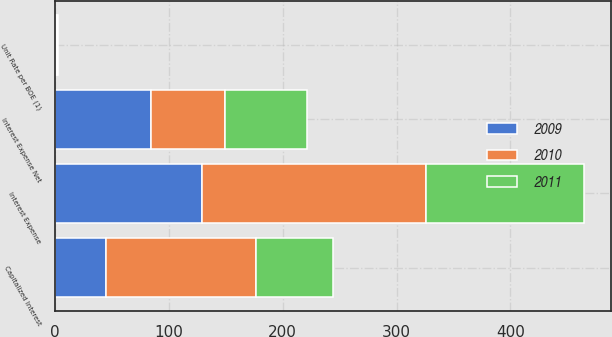Convert chart to OTSL. <chart><loc_0><loc_0><loc_500><loc_500><stacked_bar_chart><ecel><fcel>Interest Expense<fcel>Capitalized Interest<fcel>Interest Expense Net<fcel>Unit Rate per BOE (1)<nl><fcel>2010<fcel>197<fcel>132<fcel>65<fcel>0.83<nl><fcel>2011<fcel>139<fcel>67<fcel>72<fcel>0.94<nl><fcel>2009<fcel>129<fcel>45<fcel>84<fcel>1.13<nl></chart> 